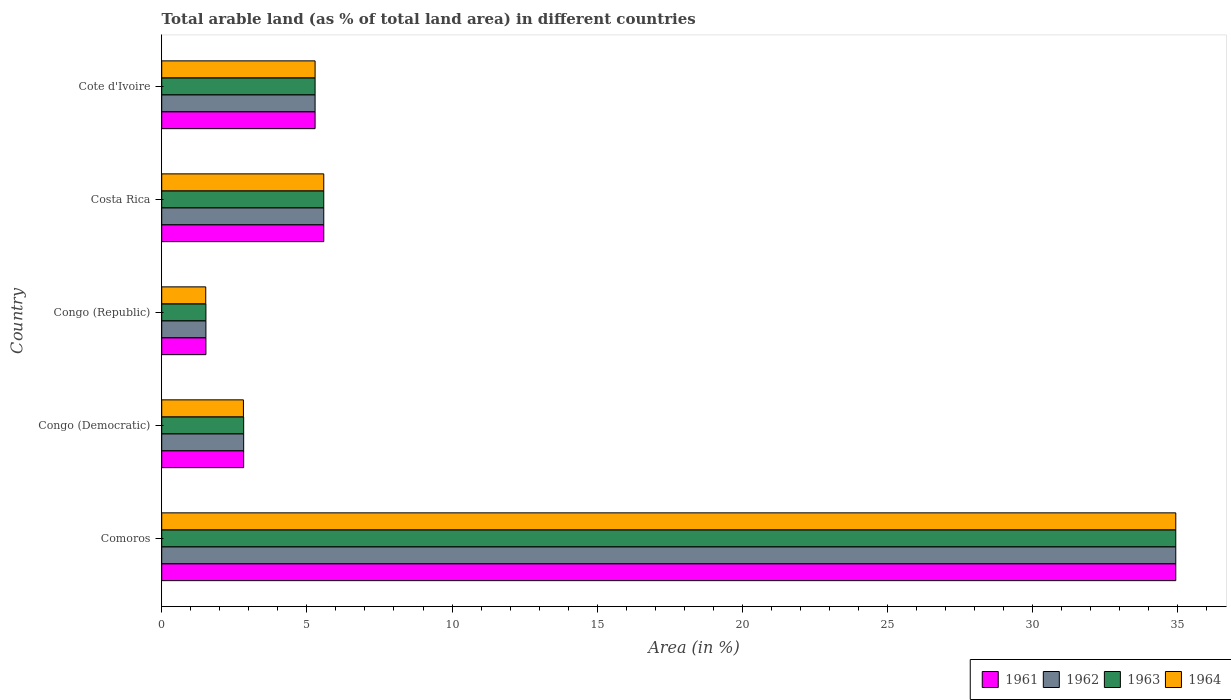Are the number of bars on each tick of the Y-axis equal?
Your answer should be compact. Yes. How many bars are there on the 3rd tick from the top?
Give a very brief answer. 4. How many bars are there on the 1st tick from the bottom?
Your answer should be compact. 4. What is the label of the 3rd group of bars from the top?
Provide a short and direct response. Congo (Republic). In how many cases, is the number of bars for a given country not equal to the number of legend labels?
Ensure brevity in your answer.  0. What is the percentage of arable land in 1961 in Costa Rica?
Offer a very short reply. 5.58. Across all countries, what is the maximum percentage of arable land in 1961?
Provide a succinct answer. 34.93. Across all countries, what is the minimum percentage of arable land in 1964?
Your response must be concise. 1.52. In which country was the percentage of arable land in 1961 maximum?
Give a very brief answer. Comoros. In which country was the percentage of arable land in 1962 minimum?
Offer a terse response. Congo (Republic). What is the total percentage of arable land in 1962 in the graph?
Make the answer very short. 50.14. What is the difference between the percentage of arable land in 1964 in Comoros and that in Congo (Republic)?
Provide a short and direct response. 33.41. What is the difference between the percentage of arable land in 1961 in Comoros and the percentage of arable land in 1962 in Congo (Republic)?
Your answer should be compact. 33.4. What is the average percentage of arable land in 1961 per country?
Give a very brief answer. 10.03. What is the difference between the percentage of arable land in 1964 and percentage of arable land in 1962 in Congo (Democratic)?
Provide a short and direct response. -0.01. In how many countries, is the percentage of arable land in 1964 greater than 31 %?
Your response must be concise. 1. What is the ratio of the percentage of arable land in 1962 in Congo (Republic) to that in Costa Rica?
Offer a very short reply. 0.27. Is the percentage of arable land in 1963 in Congo (Democratic) less than that in Congo (Republic)?
Ensure brevity in your answer.  No. What is the difference between the highest and the second highest percentage of arable land in 1961?
Keep it short and to the point. 29.35. What is the difference between the highest and the lowest percentage of arable land in 1962?
Provide a short and direct response. 33.4. In how many countries, is the percentage of arable land in 1962 greater than the average percentage of arable land in 1962 taken over all countries?
Offer a terse response. 1. Is the sum of the percentage of arable land in 1964 in Costa Rica and Cote d'Ivoire greater than the maximum percentage of arable land in 1962 across all countries?
Provide a succinct answer. No. What does the 2nd bar from the top in Cote d'Ivoire represents?
Your response must be concise. 1963. What does the 4th bar from the bottom in Congo (Democratic) represents?
Your answer should be compact. 1964. Is it the case that in every country, the sum of the percentage of arable land in 1963 and percentage of arable land in 1962 is greater than the percentage of arable land in 1961?
Offer a terse response. Yes. How many countries are there in the graph?
Offer a terse response. 5. Are the values on the major ticks of X-axis written in scientific E-notation?
Keep it short and to the point. No. Does the graph contain any zero values?
Offer a very short reply. No. Where does the legend appear in the graph?
Offer a very short reply. Bottom right. How are the legend labels stacked?
Your answer should be compact. Horizontal. What is the title of the graph?
Keep it short and to the point. Total arable land (as % of total land area) in different countries. What is the label or title of the X-axis?
Keep it short and to the point. Area (in %). What is the label or title of the Y-axis?
Provide a succinct answer. Country. What is the Area (in %) of 1961 in Comoros?
Ensure brevity in your answer.  34.93. What is the Area (in %) in 1962 in Comoros?
Make the answer very short. 34.93. What is the Area (in %) in 1963 in Comoros?
Your answer should be compact. 34.93. What is the Area (in %) in 1964 in Comoros?
Your response must be concise. 34.93. What is the Area (in %) of 1961 in Congo (Democratic)?
Keep it short and to the point. 2.82. What is the Area (in %) of 1962 in Congo (Democratic)?
Offer a very short reply. 2.82. What is the Area (in %) of 1963 in Congo (Democratic)?
Offer a very short reply. 2.82. What is the Area (in %) of 1964 in Congo (Democratic)?
Your response must be concise. 2.81. What is the Area (in %) of 1961 in Congo (Republic)?
Provide a short and direct response. 1.52. What is the Area (in %) in 1962 in Congo (Republic)?
Provide a succinct answer. 1.52. What is the Area (in %) in 1963 in Congo (Republic)?
Provide a succinct answer. 1.52. What is the Area (in %) in 1964 in Congo (Republic)?
Your response must be concise. 1.52. What is the Area (in %) of 1961 in Costa Rica?
Ensure brevity in your answer.  5.58. What is the Area (in %) in 1962 in Costa Rica?
Your response must be concise. 5.58. What is the Area (in %) of 1963 in Costa Rica?
Offer a very short reply. 5.58. What is the Area (in %) of 1964 in Costa Rica?
Offer a terse response. 5.58. What is the Area (in %) in 1961 in Cote d'Ivoire?
Your response must be concise. 5.28. What is the Area (in %) of 1962 in Cote d'Ivoire?
Provide a succinct answer. 5.28. What is the Area (in %) of 1963 in Cote d'Ivoire?
Your response must be concise. 5.28. What is the Area (in %) of 1964 in Cote d'Ivoire?
Provide a short and direct response. 5.28. Across all countries, what is the maximum Area (in %) in 1961?
Your answer should be compact. 34.93. Across all countries, what is the maximum Area (in %) of 1962?
Your answer should be very brief. 34.93. Across all countries, what is the maximum Area (in %) in 1963?
Offer a very short reply. 34.93. Across all countries, what is the maximum Area (in %) of 1964?
Offer a terse response. 34.93. Across all countries, what is the minimum Area (in %) in 1961?
Provide a short and direct response. 1.52. Across all countries, what is the minimum Area (in %) of 1962?
Offer a very short reply. 1.52. Across all countries, what is the minimum Area (in %) of 1963?
Your answer should be very brief. 1.52. Across all countries, what is the minimum Area (in %) in 1964?
Give a very brief answer. 1.52. What is the total Area (in %) of 1961 in the graph?
Your response must be concise. 50.14. What is the total Area (in %) in 1962 in the graph?
Your response must be concise. 50.14. What is the total Area (in %) in 1963 in the graph?
Offer a terse response. 50.14. What is the total Area (in %) in 1964 in the graph?
Your answer should be very brief. 50.12. What is the difference between the Area (in %) of 1961 in Comoros and that in Congo (Democratic)?
Ensure brevity in your answer.  32.1. What is the difference between the Area (in %) in 1962 in Comoros and that in Congo (Democratic)?
Your answer should be compact. 32.1. What is the difference between the Area (in %) in 1963 in Comoros and that in Congo (Democratic)?
Offer a very short reply. 32.1. What is the difference between the Area (in %) of 1964 in Comoros and that in Congo (Democratic)?
Offer a terse response. 32.11. What is the difference between the Area (in %) in 1961 in Comoros and that in Congo (Republic)?
Keep it short and to the point. 33.4. What is the difference between the Area (in %) of 1962 in Comoros and that in Congo (Republic)?
Your response must be concise. 33.4. What is the difference between the Area (in %) in 1963 in Comoros and that in Congo (Republic)?
Provide a succinct answer. 33.4. What is the difference between the Area (in %) of 1964 in Comoros and that in Congo (Republic)?
Provide a succinct answer. 33.41. What is the difference between the Area (in %) in 1961 in Comoros and that in Costa Rica?
Keep it short and to the point. 29.35. What is the difference between the Area (in %) of 1962 in Comoros and that in Costa Rica?
Your response must be concise. 29.35. What is the difference between the Area (in %) of 1963 in Comoros and that in Costa Rica?
Your response must be concise. 29.35. What is the difference between the Area (in %) of 1964 in Comoros and that in Costa Rica?
Provide a succinct answer. 29.35. What is the difference between the Area (in %) in 1961 in Comoros and that in Cote d'Ivoire?
Give a very brief answer. 29.64. What is the difference between the Area (in %) of 1962 in Comoros and that in Cote d'Ivoire?
Provide a succinct answer. 29.64. What is the difference between the Area (in %) in 1963 in Comoros and that in Cote d'Ivoire?
Give a very brief answer. 29.64. What is the difference between the Area (in %) of 1964 in Comoros and that in Cote d'Ivoire?
Make the answer very short. 29.64. What is the difference between the Area (in %) in 1961 in Congo (Democratic) and that in Congo (Republic)?
Provide a succinct answer. 1.3. What is the difference between the Area (in %) in 1962 in Congo (Democratic) and that in Congo (Republic)?
Offer a very short reply. 1.3. What is the difference between the Area (in %) of 1963 in Congo (Democratic) and that in Congo (Republic)?
Provide a short and direct response. 1.3. What is the difference between the Area (in %) in 1964 in Congo (Democratic) and that in Congo (Republic)?
Your answer should be very brief. 1.3. What is the difference between the Area (in %) of 1961 in Congo (Democratic) and that in Costa Rica?
Keep it short and to the point. -2.76. What is the difference between the Area (in %) in 1962 in Congo (Democratic) and that in Costa Rica?
Give a very brief answer. -2.76. What is the difference between the Area (in %) in 1963 in Congo (Democratic) and that in Costa Rica?
Your response must be concise. -2.76. What is the difference between the Area (in %) in 1964 in Congo (Democratic) and that in Costa Rica?
Give a very brief answer. -2.77. What is the difference between the Area (in %) in 1961 in Congo (Democratic) and that in Cote d'Ivoire?
Provide a short and direct response. -2.46. What is the difference between the Area (in %) in 1962 in Congo (Democratic) and that in Cote d'Ivoire?
Make the answer very short. -2.46. What is the difference between the Area (in %) in 1963 in Congo (Democratic) and that in Cote d'Ivoire?
Provide a short and direct response. -2.46. What is the difference between the Area (in %) in 1964 in Congo (Democratic) and that in Cote d'Ivoire?
Provide a succinct answer. -2.47. What is the difference between the Area (in %) in 1961 in Congo (Republic) and that in Costa Rica?
Your answer should be very brief. -4.06. What is the difference between the Area (in %) of 1962 in Congo (Republic) and that in Costa Rica?
Make the answer very short. -4.06. What is the difference between the Area (in %) in 1963 in Congo (Republic) and that in Costa Rica?
Make the answer very short. -4.06. What is the difference between the Area (in %) of 1964 in Congo (Republic) and that in Costa Rica?
Ensure brevity in your answer.  -4.06. What is the difference between the Area (in %) of 1961 in Congo (Republic) and that in Cote d'Ivoire?
Offer a very short reply. -3.76. What is the difference between the Area (in %) in 1962 in Congo (Republic) and that in Cote d'Ivoire?
Ensure brevity in your answer.  -3.76. What is the difference between the Area (in %) in 1963 in Congo (Republic) and that in Cote d'Ivoire?
Your answer should be very brief. -3.76. What is the difference between the Area (in %) in 1964 in Congo (Republic) and that in Cote d'Ivoire?
Your response must be concise. -3.77. What is the difference between the Area (in %) in 1961 in Costa Rica and that in Cote d'Ivoire?
Keep it short and to the point. 0.3. What is the difference between the Area (in %) of 1962 in Costa Rica and that in Cote d'Ivoire?
Ensure brevity in your answer.  0.3. What is the difference between the Area (in %) of 1963 in Costa Rica and that in Cote d'Ivoire?
Provide a short and direct response. 0.3. What is the difference between the Area (in %) in 1964 in Costa Rica and that in Cote d'Ivoire?
Make the answer very short. 0.3. What is the difference between the Area (in %) of 1961 in Comoros and the Area (in %) of 1962 in Congo (Democratic)?
Provide a short and direct response. 32.1. What is the difference between the Area (in %) of 1961 in Comoros and the Area (in %) of 1963 in Congo (Democratic)?
Your answer should be very brief. 32.1. What is the difference between the Area (in %) in 1961 in Comoros and the Area (in %) in 1964 in Congo (Democratic)?
Ensure brevity in your answer.  32.11. What is the difference between the Area (in %) of 1962 in Comoros and the Area (in %) of 1963 in Congo (Democratic)?
Keep it short and to the point. 32.1. What is the difference between the Area (in %) of 1962 in Comoros and the Area (in %) of 1964 in Congo (Democratic)?
Offer a terse response. 32.11. What is the difference between the Area (in %) in 1963 in Comoros and the Area (in %) in 1964 in Congo (Democratic)?
Ensure brevity in your answer.  32.11. What is the difference between the Area (in %) of 1961 in Comoros and the Area (in %) of 1962 in Congo (Republic)?
Offer a terse response. 33.4. What is the difference between the Area (in %) in 1961 in Comoros and the Area (in %) in 1963 in Congo (Republic)?
Offer a very short reply. 33.4. What is the difference between the Area (in %) in 1961 in Comoros and the Area (in %) in 1964 in Congo (Republic)?
Provide a short and direct response. 33.41. What is the difference between the Area (in %) of 1962 in Comoros and the Area (in %) of 1963 in Congo (Republic)?
Your answer should be compact. 33.4. What is the difference between the Area (in %) in 1962 in Comoros and the Area (in %) in 1964 in Congo (Republic)?
Provide a short and direct response. 33.41. What is the difference between the Area (in %) of 1963 in Comoros and the Area (in %) of 1964 in Congo (Republic)?
Offer a very short reply. 33.41. What is the difference between the Area (in %) of 1961 in Comoros and the Area (in %) of 1962 in Costa Rica?
Ensure brevity in your answer.  29.35. What is the difference between the Area (in %) in 1961 in Comoros and the Area (in %) in 1963 in Costa Rica?
Give a very brief answer. 29.35. What is the difference between the Area (in %) in 1961 in Comoros and the Area (in %) in 1964 in Costa Rica?
Provide a succinct answer. 29.35. What is the difference between the Area (in %) in 1962 in Comoros and the Area (in %) in 1963 in Costa Rica?
Ensure brevity in your answer.  29.35. What is the difference between the Area (in %) of 1962 in Comoros and the Area (in %) of 1964 in Costa Rica?
Offer a terse response. 29.35. What is the difference between the Area (in %) of 1963 in Comoros and the Area (in %) of 1964 in Costa Rica?
Give a very brief answer. 29.35. What is the difference between the Area (in %) of 1961 in Comoros and the Area (in %) of 1962 in Cote d'Ivoire?
Make the answer very short. 29.64. What is the difference between the Area (in %) of 1961 in Comoros and the Area (in %) of 1963 in Cote d'Ivoire?
Offer a terse response. 29.64. What is the difference between the Area (in %) in 1961 in Comoros and the Area (in %) in 1964 in Cote d'Ivoire?
Give a very brief answer. 29.64. What is the difference between the Area (in %) of 1962 in Comoros and the Area (in %) of 1963 in Cote d'Ivoire?
Your answer should be very brief. 29.64. What is the difference between the Area (in %) in 1962 in Comoros and the Area (in %) in 1964 in Cote d'Ivoire?
Offer a very short reply. 29.64. What is the difference between the Area (in %) in 1963 in Comoros and the Area (in %) in 1964 in Cote d'Ivoire?
Provide a succinct answer. 29.64. What is the difference between the Area (in %) of 1961 in Congo (Democratic) and the Area (in %) of 1962 in Congo (Republic)?
Give a very brief answer. 1.3. What is the difference between the Area (in %) in 1961 in Congo (Democratic) and the Area (in %) in 1963 in Congo (Republic)?
Your answer should be very brief. 1.3. What is the difference between the Area (in %) in 1961 in Congo (Democratic) and the Area (in %) in 1964 in Congo (Republic)?
Provide a short and direct response. 1.31. What is the difference between the Area (in %) in 1962 in Congo (Democratic) and the Area (in %) in 1963 in Congo (Republic)?
Ensure brevity in your answer.  1.3. What is the difference between the Area (in %) in 1962 in Congo (Democratic) and the Area (in %) in 1964 in Congo (Republic)?
Your answer should be very brief. 1.31. What is the difference between the Area (in %) of 1963 in Congo (Democratic) and the Area (in %) of 1964 in Congo (Republic)?
Make the answer very short. 1.31. What is the difference between the Area (in %) in 1961 in Congo (Democratic) and the Area (in %) in 1962 in Costa Rica?
Ensure brevity in your answer.  -2.76. What is the difference between the Area (in %) in 1961 in Congo (Democratic) and the Area (in %) in 1963 in Costa Rica?
Provide a succinct answer. -2.76. What is the difference between the Area (in %) of 1961 in Congo (Democratic) and the Area (in %) of 1964 in Costa Rica?
Provide a succinct answer. -2.76. What is the difference between the Area (in %) in 1962 in Congo (Democratic) and the Area (in %) in 1963 in Costa Rica?
Ensure brevity in your answer.  -2.76. What is the difference between the Area (in %) in 1962 in Congo (Democratic) and the Area (in %) in 1964 in Costa Rica?
Keep it short and to the point. -2.76. What is the difference between the Area (in %) in 1963 in Congo (Democratic) and the Area (in %) in 1964 in Costa Rica?
Provide a short and direct response. -2.76. What is the difference between the Area (in %) of 1961 in Congo (Democratic) and the Area (in %) of 1962 in Cote d'Ivoire?
Make the answer very short. -2.46. What is the difference between the Area (in %) in 1961 in Congo (Democratic) and the Area (in %) in 1963 in Cote d'Ivoire?
Your response must be concise. -2.46. What is the difference between the Area (in %) of 1961 in Congo (Democratic) and the Area (in %) of 1964 in Cote d'Ivoire?
Your answer should be very brief. -2.46. What is the difference between the Area (in %) in 1962 in Congo (Democratic) and the Area (in %) in 1963 in Cote d'Ivoire?
Your answer should be compact. -2.46. What is the difference between the Area (in %) of 1962 in Congo (Democratic) and the Area (in %) of 1964 in Cote d'Ivoire?
Keep it short and to the point. -2.46. What is the difference between the Area (in %) of 1963 in Congo (Democratic) and the Area (in %) of 1964 in Cote d'Ivoire?
Offer a terse response. -2.46. What is the difference between the Area (in %) in 1961 in Congo (Republic) and the Area (in %) in 1962 in Costa Rica?
Offer a very short reply. -4.06. What is the difference between the Area (in %) in 1961 in Congo (Republic) and the Area (in %) in 1963 in Costa Rica?
Make the answer very short. -4.06. What is the difference between the Area (in %) of 1961 in Congo (Republic) and the Area (in %) of 1964 in Costa Rica?
Make the answer very short. -4.06. What is the difference between the Area (in %) of 1962 in Congo (Republic) and the Area (in %) of 1963 in Costa Rica?
Offer a very short reply. -4.06. What is the difference between the Area (in %) in 1962 in Congo (Republic) and the Area (in %) in 1964 in Costa Rica?
Provide a short and direct response. -4.06. What is the difference between the Area (in %) of 1963 in Congo (Republic) and the Area (in %) of 1964 in Costa Rica?
Your answer should be very brief. -4.06. What is the difference between the Area (in %) of 1961 in Congo (Republic) and the Area (in %) of 1962 in Cote d'Ivoire?
Make the answer very short. -3.76. What is the difference between the Area (in %) in 1961 in Congo (Republic) and the Area (in %) in 1963 in Cote d'Ivoire?
Your answer should be compact. -3.76. What is the difference between the Area (in %) of 1961 in Congo (Republic) and the Area (in %) of 1964 in Cote d'Ivoire?
Your response must be concise. -3.76. What is the difference between the Area (in %) of 1962 in Congo (Republic) and the Area (in %) of 1963 in Cote d'Ivoire?
Provide a succinct answer. -3.76. What is the difference between the Area (in %) in 1962 in Congo (Republic) and the Area (in %) in 1964 in Cote d'Ivoire?
Provide a short and direct response. -3.76. What is the difference between the Area (in %) of 1963 in Congo (Republic) and the Area (in %) of 1964 in Cote d'Ivoire?
Your answer should be compact. -3.76. What is the difference between the Area (in %) of 1961 in Costa Rica and the Area (in %) of 1962 in Cote d'Ivoire?
Offer a very short reply. 0.3. What is the difference between the Area (in %) of 1961 in Costa Rica and the Area (in %) of 1963 in Cote d'Ivoire?
Your response must be concise. 0.3. What is the difference between the Area (in %) of 1961 in Costa Rica and the Area (in %) of 1964 in Cote d'Ivoire?
Keep it short and to the point. 0.3. What is the difference between the Area (in %) in 1962 in Costa Rica and the Area (in %) in 1963 in Cote d'Ivoire?
Your answer should be very brief. 0.3. What is the difference between the Area (in %) of 1962 in Costa Rica and the Area (in %) of 1964 in Cote d'Ivoire?
Your answer should be very brief. 0.3. What is the difference between the Area (in %) in 1963 in Costa Rica and the Area (in %) in 1964 in Cote d'Ivoire?
Your answer should be compact. 0.3. What is the average Area (in %) of 1961 per country?
Offer a terse response. 10.03. What is the average Area (in %) in 1962 per country?
Your response must be concise. 10.03. What is the average Area (in %) of 1963 per country?
Give a very brief answer. 10.03. What is the average Area (in %) in 1964 per country?
Make the answer very short. 10.02. What is the difference between the Area (in %) of 1961 and Area (in %) of 1963 in Comoros?
Make the answer very short. 0. What is the difference between the Area (in %) in 1962 and Area (in %) in 1964 in Comoros?
Provide a succinct answer. 0. What is the difference between the Area (in %) in 1961 and Area (in %) in 1964 in Congo (Democratic)?
Provide a short and direct response. 0.01. What is the difference between the Area (in %) in 1962 and Area (in %) in 1964 in Congo (Democratic)?
Offer a very short reply. 0.01. What is the difference between the Area (in %) of 1963 and Area (in %) of 1964 in Congo (Democratic)?
Give a very brief answer. 0.01. What is the difference between the Area (in %) of 1961 and Area (in %) of 1962 in Congo (Republic)?
Your answer should be very brief. 0. What is the difference between the Area (in %) in 1961 and Area (in %) in 1964 in Congo (Republic)?
Offer a terse response. 0.01. What is the difference between the Area (in %) in 1962 and Area (in %) in 1964 in Congo (Republic)?
Your answer should be compact. 0.01. What is the difference between the Area (in %) of 1963 and Area (in %) of 1964 in Congo (Republic)?
Your response must be concise. 0.01. What is the difference between the Area (in %) in 1961 and Area (in %) in 1962 in Costa Rica?
Ensure brevity in your answer.  0. What is the difference between the Area (in %) of 1961 and Area (in %) of 1963 in Costa Rica?
Offer a very short reply. 0. What is the difference between the Area (in %) in 1961 and Area (in %) in 1964 in Costa Rica?
Offer a terse response. 0. What is the difference between the Area (in %) in 1962 and Area (in %) in 1963 in Costa Rica?
Ensure brevity in your answer.  0. What is the difference between the Area (in %) in 1963 and Area (in %) in 1964 in Costa Rica?
Give a very brief answer. 0. What is the difference between the Area (in %) in 1961 and Area (in %) in 1962 in Cote d'Ivoire?
Give a very brief answer. 0. What is the difference between the Area (in %) of 1961 and Area (in %) of 1963 in Cote d'Ivoire?
Provide a succinct answer. 0. What is the difference between the Area (in %) in 1962 and Area (in %) in 1963 in Cote d'Ivoire?
Your response must be concise. 0. What is the difference between the Area (in %) in 1962 and Area (in %) in 1964 in Cote d'Ivoire?
Give a very brief answer. 0. What is the difference between the Area (in %) of 1963 and Area (in %) of 1964 in Cote d'Ivoire?
Give a very brief answer. 0. What is the ratio of the Area (in %) of 1961 in Comoros to that in Congo (Democratic)?
Provide a succinct answer. 12.37. What is the ratio of the Area (in %) in 1962 in Comoros to that in Congo (Democratic)?
Offer a terse response. 12.37. What is the ratio of the Area (in %) of 1963 in Comoros to that in Congo (Democratic)?
Provide a short and direct response. 12.37. What is the ratio of the Area (in %) in 1964 in Comoros to that in Congo (Democratic)?
Keep it short and to the point. 12.41. What is the ratio of the Area (in %) of 1961 in Comoros to that in Congo (Republic)?
Ensure brevity in your answer.  22.94. What is the ratio of the Area (in %) of 1962 in Comoros to that in Congo (Republic)?
Your answer should be very brief. 22.94. What is the ratio of the Area (in %) in 1963 in Comoros to that in Congo (Republic)?
Your answer should be very brief. 22.94. What is the ratio of the Area (in %) of 1964 in Comoros to that in Congo (Republic)?
Keep it short and to the point. 23.03. What is the ratio of the Area (in %) in 1961 in Comoros to that in Costa Rica?
Ensure brevity in your answer.  6.26. What is the ratio of the Area (in %) in 1962 in Comoros to that in Costa Rica?
Make the answer very short. 6.26. What is the ratio of the Area (in %) in 1963 in Comoros to that in Costa Rica?
Offer a terse response. 6.26. What is the ratio of the Area (in %) in 1964 in Comoros to that in Costa Rica?
Provide a succinct answer. 6.26. What is the ratio of the Area (in %) of 1961 in Comoros to that in Cote d'Ivoire?
Ensure brevity in your answer.  6.61. What is the ratio of the Area (in %) in 1962 in Comoros to that in Cote d'Ivoire?
Make the answer very short. 6.61. What is the ratio of the Area (in %) of 1963 in Comoros to that in Cote d'Ivoire?
Your answer should be very brief. 6.61. What is the ratio of the Area (in %) of 1964 in Comoros to that in Cote d'Ivoire?
Your response must be concise. 6.61. What is the ratio of the Area (in %) of 1961 in Congo (Democratic) to that in Congo (Republic)?
Your answer should be very brief. 1.85. What is the ratio of the Area (in %) in 1962 in Congo (Democratic) to that in Congo (Republic)?
Your answer should be very brief. 1.85. What is the ratio of the Area (in %) of 1963 in Congo (Democratic) to that in Congo (Republic)?
Your answer should be very brief. 1.85. What is the ratio of the Area (in %) in 1964 in Congo (Democratic) to that in Congo (Republic)?
Provide a short and direct response. 1.86. What is the ratio of the Area (in %) in 1961 in Congo (Democratic) to that in Costa Rica?
Your response must be concise. 0.51. What is the ratio of the Area (in %) in 1962 in Congo (Democratic) to that in Costa Rica?
Your response must be concise. 0.51. What is the ratio of the Area (in %) in 1963 in Congo (Democratic) to that in Costa Rica?
Provide a succinct answer. 0.51. What is the ratio of the Area (in %) in 1964 in Congo (Democratic) to that in Costa Rica?
Provide a succinct answer. 0.5. What is the ratio of the Area (in %) in 1961 in Congo (Democratic) to that in Cote d'Ivoire?
Offer a very short reply. 0.53. What is the ratio of the Area (in %) of 1962 in Congo (Democratic) to that in Cote d'Ivoire?
Keep it short and to the point. 0.53. What is the ratio of the Area (in %) of 1963 in Congo (Democratic) to that in Cote d'Ivoire?
Offer a terse response. 0.53. What is the ratio of the Area (in %) of 1964 in Congo (Democratic) to that in Cote d'Ivoire?
Your response must be concise. 0.53. What is the ratio of the Area (in %) of 1961 in Congo (Republic) to that in Costa Rica?
Offer a terse response. 0.27. What is the ratio of the Area (in %) of 1962 in Congo (Republic) to that in Costa Rica?
Your answer should be compact. 0.27. What is the ratio of the Area (in %) in 1963 in Congo (Republic) to that in Costa Rica?
Keep it short and to the point. 0.27. What is the ratio of the Area (in %) in 1964 in Congo (Republic) to that in Costa Rica?
Give a very brief answer. 0.27. What is the ratio of the Area (in %) in 1961 in Congo (Republic) to that in Cote d'Ivoire?
Your response must be concise. 0.29. What is the ratio of the Area (in %) in 1962 in Congo (Republic) to that in Cote d'Ivoire?
Offer a terse response. 0.29. What is the ratio of the Area (in %) of 1963 in Congo (Republic) to that in Cote d'Ivoire?
Ensure brevity in your answer.  0.29. What is the ratio of the Area (in %) of 1964 in Congo (Republic) to that in Cote d'Ivoire?
Keep it short and to the point. 0.29. What is the ratio of the Area (in %) of 1961 in Costa Rica to that in Cote d'Ivoire?
Provide a succinct answer. 1.06. What is the ratio of the Area (in %) in 1962 in Costa Rica to that in Cote d'Ivoire?
Your answer should be very brief. 1.06. What is the ratio of the Area (in %) of 1963 in Costa Rica to that in Cote d'Ivoire?
Give a very brief answer. 1.06. What is the ratio of the Area (in %) in 1964 in Costa Rica to that in Cote d'Ivoire?
Make the answer very short. 1.06. What is the difference between the highest and the second highest Area (in %) in 1961?
Provide a succinct answer. 29.35. What is the difference between the highest and the second highest Area (in %) of 1962?
Offer a very short reply. 29.35. What is the difference between the highest and the second highest Area (in %) of 1963?
Your response must be concise. 29.35. What is the difference between the highest and the second highest Area (in %) in 1964?
Give a very brief answer. 29.35. What is the difference between the highest and the lowest Area (in %) of 1961?
Give a very brief answer. 33.4. What is the difference between the highest and the lowest Area (in %) in 1962?
Provide a short and direct response. 33.4. What is the difference between the highest and the lowest Area (in %) in 1963?
Offer a terse response. 33.4. What is the difference between the highest and the lowest Area (in %) in 1964?
Give a very brief answer. 33.41. 